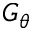Convert formula to latex. <formula><loc_0><loc_0><loc_500><loc_500>G _ { \theta }</formula> 